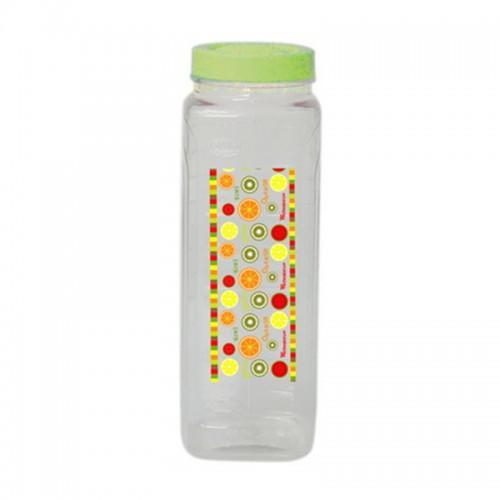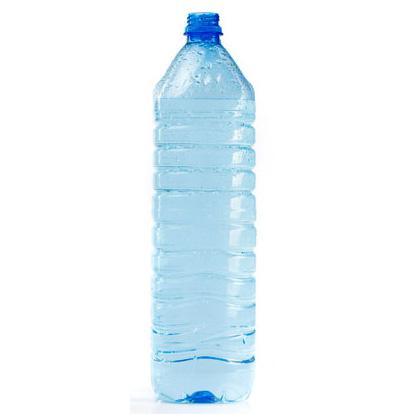The first image is the image on the left, the second image is the image on the right. For the images displayed, is the sentence "There is a reusable water bottle on the left and a disposable bottle on the right." factually correct? Answer yes or no. Yes. The first image is the image on the left, the second image is the image on the right. Evaluate the accuracy of this statement regarding the images: "The bottle caps are all blue.". Is it true? Answer yes or no. No. 